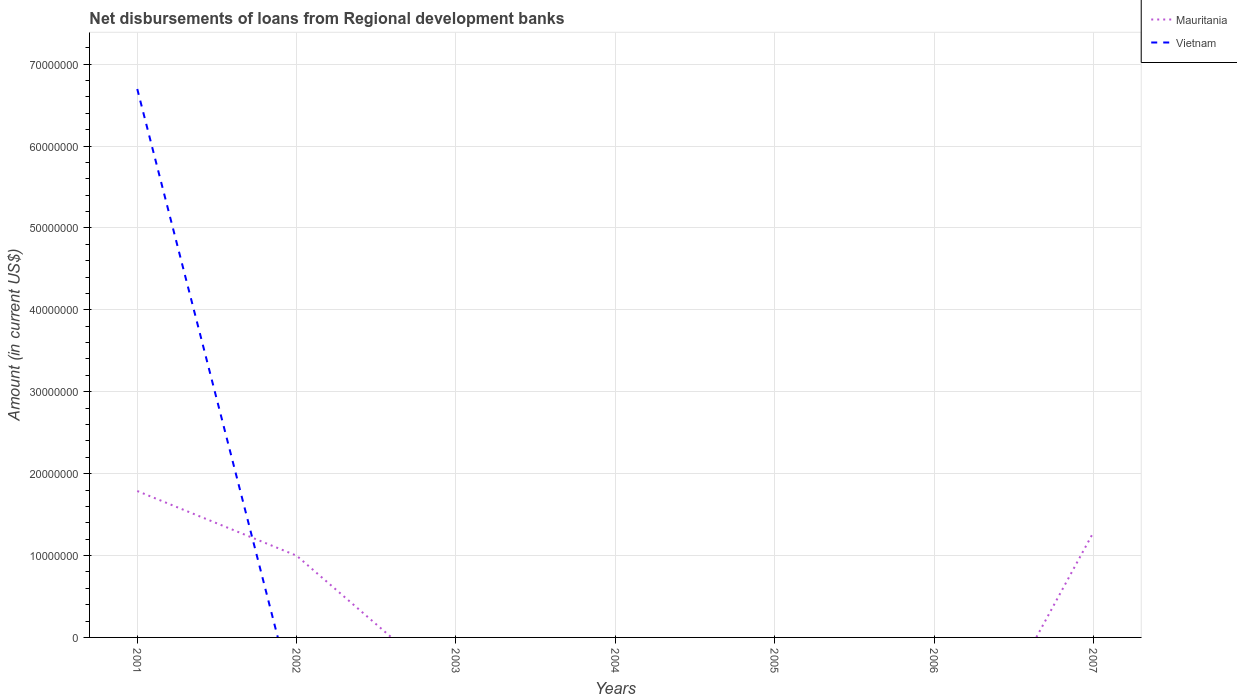Does the line corresponding to Vietnam intersect with the line corresponding to Mauritania?
Give a very brief answer. Yes. What is the total amount of disbursements of loans from regional development banks in Mauritania in the graph?
Your answer should be compact. 7.90e+06. What is the difference between the highest and the second highest amount of disbursements of loans from regional development banks in Vietnam?
Offer a very short reply. 6.70e+07. What is the difference between the highest and the lowest amount of disbursements of loans from regional development banks in Vietnam?
Your answer should be compact. 1. Is the amount of disbursements of loans from regional development banks in Vietnam strictly greater than the amount of disbursements of loans from regional development banks in Mauritania over the years?
Ensure brevity in your answer.  No. What is the difference between two consecutive major ticks on the Y-axis?
Ensure brevity in your answer.  1.00e+07. Does the graph contain any zero values?
Your answer should be very brief. Yes. Does the graph contain grids?
Provide a short and direct response. Yes. How many legend labels are there?
Make the answer very short. 2. What is the title of the graph?
Your answer should be very brief. Net disbursements of loans from Regional development banks. What is the label or title of the Y-axis?
Offer a very short reply. Amount (in current US$). What is the Amount (in current US$) of Mauritania in 2001?
Give a very brief answer. 1.79e+07. What is the Amount (in current US$) of Vietnam in 2001?
Your answer should be compact. 6.70e+07. What is the Amount (in current US$) of Mauritania in 2002?
Make the answer very short. 9.98e+06. What is the Amount (in current US$) in Vietnam in 2002?
Keep it short and to the point. 0. What is the Amount (in current US$) of Mauritania in 2004?
Your answer should be compact. 0. What is the Amount (in current US$) of Mauritania in 2005?
Offer a very short reply. 0. What is the Amount (in current US$) of Vietnam in 2006?
Ensure brevity in your answer.  0. What is the Amount (in current US$) in Mauritania in 2007?
Your response must be concise. 1.28e+07. Across all years, what is the maximum Amount (in current US$) of Mauritania?
Your response must be concise. 1.79e+07. Across all years, what is the maximum Amount (in current US$) in Vietnam?
Provide a short and direct response. 6.70e+07. Across all years, what is the minimum Amount (in current US$) in Vietnam?
Ensure brevity in your answer.  0. What is the total Amount (in current US$) in Mauritania in the graph?
Your response must be concise. 4.07e+07. What is the total Amount (in current US$) of Vietnam in the graph?
Keep it short and to the point. 6.70e+07. What is the difference between the Amount (in current US$) of Mauritania in 2001 and that in 2002?
Your answer should be compact. 7.90e+06. What is the difference between the Amount (in current US$) of Mauritania in 2001 and that in 2007?
Make the answer very short. 5.05e+06. What is the difference between the Amount (in current US$) of Mauritania in 2002 and that in 2007?
Offer a very short reply. -2.85e+06. What is the average Amount (in current US$) of Mauritania per year?
Ensure brevity in your answer.  5.81e+06. What is the average Amount (in current US$) in Vietnam per year?
Your answer should be compact. 9.57e+06. In the year 2001, what is the difference between the Amount (in current US$) in Mauritania and Amount (in current US$) in Vietnam?
Your answer should be compact. -4.91e+07. What is the ratio of the Amount (in current US$) in Mauritania in 2001 to that in 2002?
Provide a succinct answer. 1.79. What is the ratio of the Amount (in current US$) of Mauritania in 2001 to that in 2007?
Give a very brief answer. 1.39. What is the ratio of the Amount (in current US$) of Mauritania in 2002 to that in 2007?
Keep it short and to the point. 0.78. What is the difference between the highest and the second highest Amount (in current US$) of Mauritania?
Make the answer very short. 5.05e+06. What is the difference between the highest and the lowest Amount (in current US$) in Mauritania?
Offer a terse response. 1.79e+07. What is the difference between the highest and the lowest Amount (in current US$) of Vietnam?
Your response must be concise. 6.70e+07. 